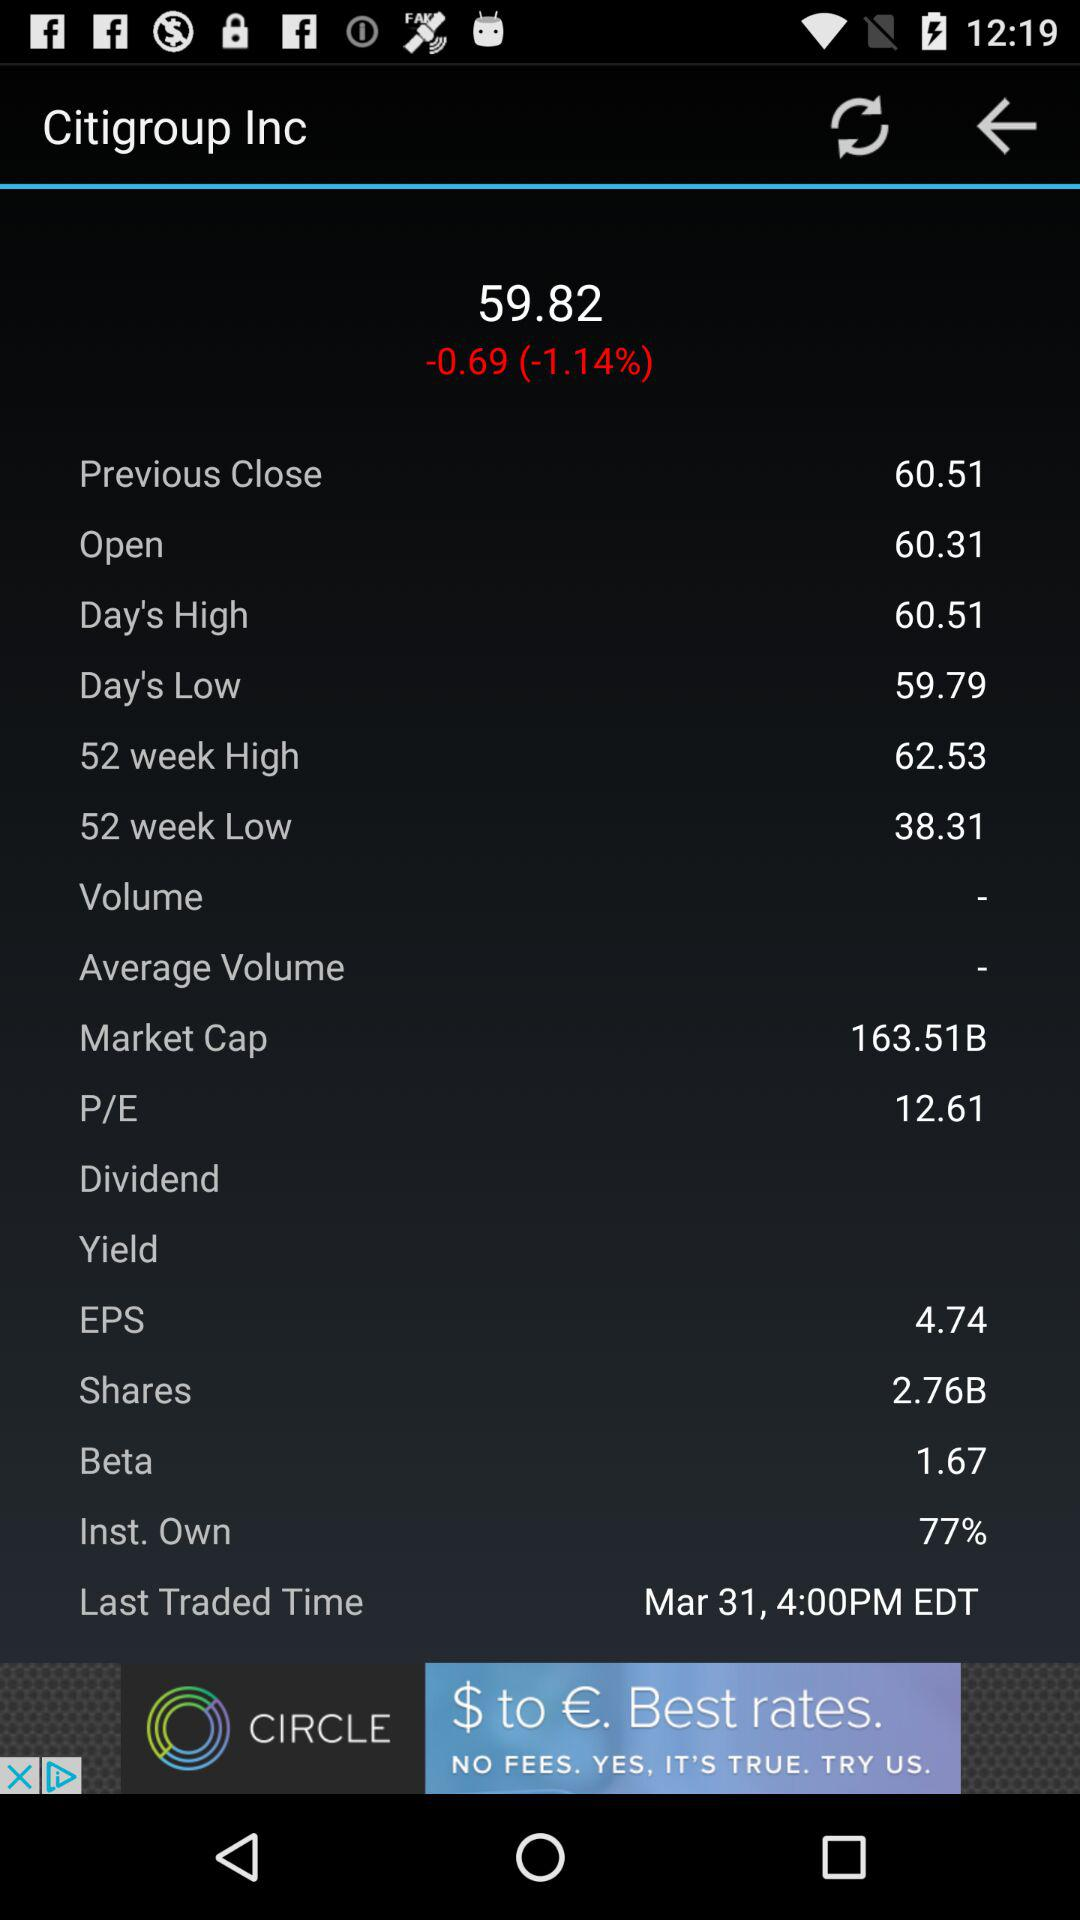What is the previous close value? The previous close value is 60.51. 